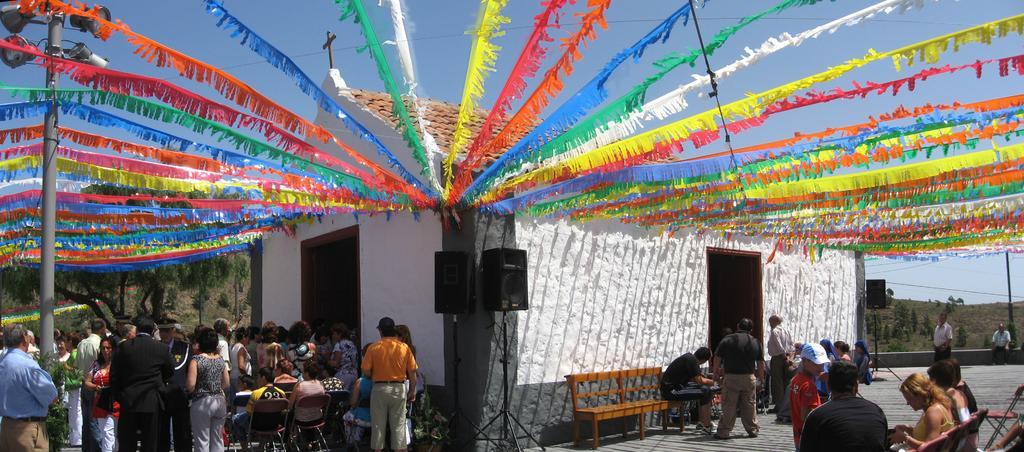How would you summarize this image in a sentence or two? In this picture we can see a group of people, some people are standing, some people are sitting on chairs, here we can see a bench, house, cross, decorative flags, electric poles, speakers, trees and we can see sky in the background. 